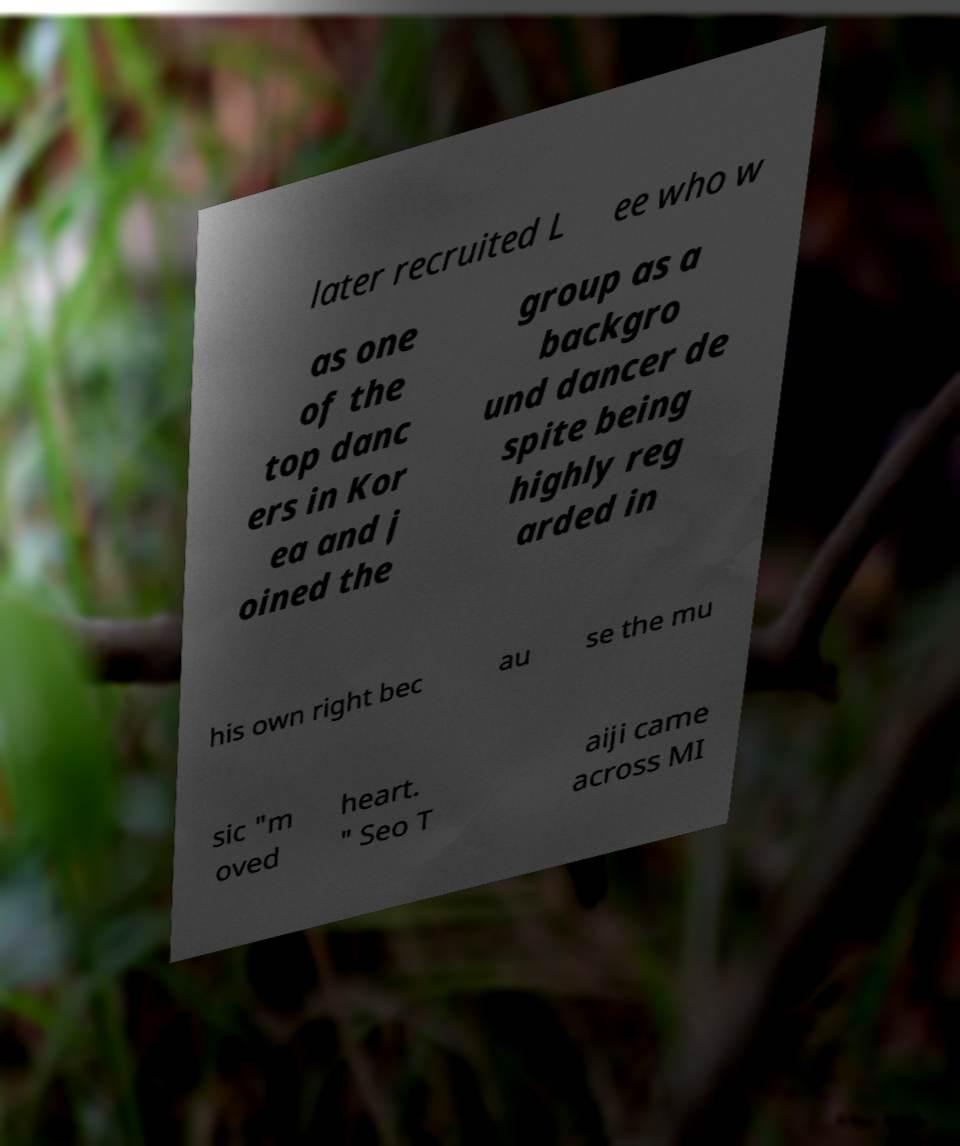Could you extract and type out the text from this image? later recruited L ee who w as one of the top danc ers in Kor ea and j oined the group as a backgro und dancer de spite being highly reg arded in his own right bec au se the mu sic "m oved heart. " Seo T aiji came across MI 